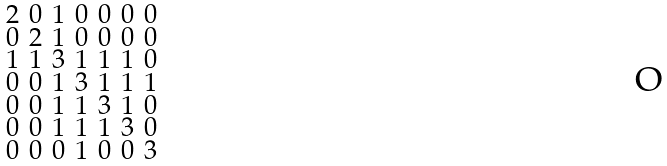<formula> <loc_0><loc_0><loc_500><loc_500>\begin{smallmatrix} 2 & 0 & 1 & 0 & 0 & 0 & 0 \\ 0 & 2 & 1 & 0 & 0 & 0 & 0 \\ 1 & 1 & 3 & 1 & 1 & 1 & 0 \\ 0 & 0 & 1 & 3 & 1 & 1 & 1 \\ 0 & 0 & 1 & 1 & 3 & 1 & 0 \\ 0 & 0 & 1 & 1 & 1 & 3 & 0 \\ 0 & 0 & 0 & 1 & 0 & 0 & 3 \end{smallmatrix}</formula> 